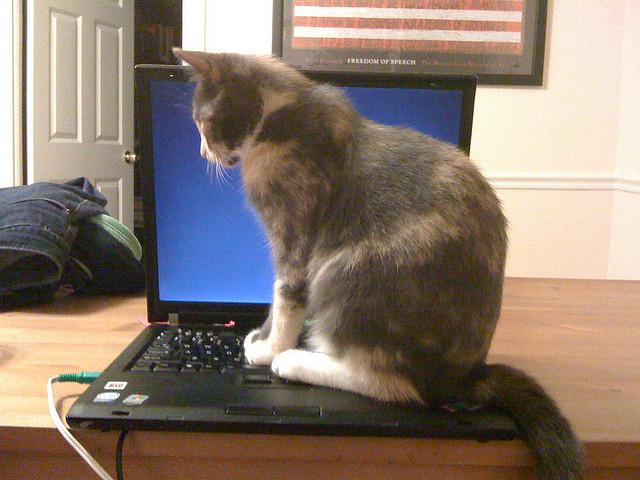Is the door closed?
Short answer required. No. What is next to the computer?
Concise answer only. Jeans. What is the cat doing?
Short answer required. Sitting. 